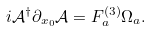Convert formula to latex. <formula><loc_0><loc_0><loc_500><loc_500>i \mathcal { A } ^ { \dagger } \partial _ { x _ { 0 } } { \mathcal { A } } = F ^ { ( 3 ) } _ { a } \Omega _ { a } .</formula> 